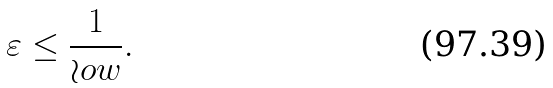<formula> <loc_0><loc_0><loc_500><loc_500>\varepsilon & \leq \frac { 1 } { \wr o w } .</formula> 